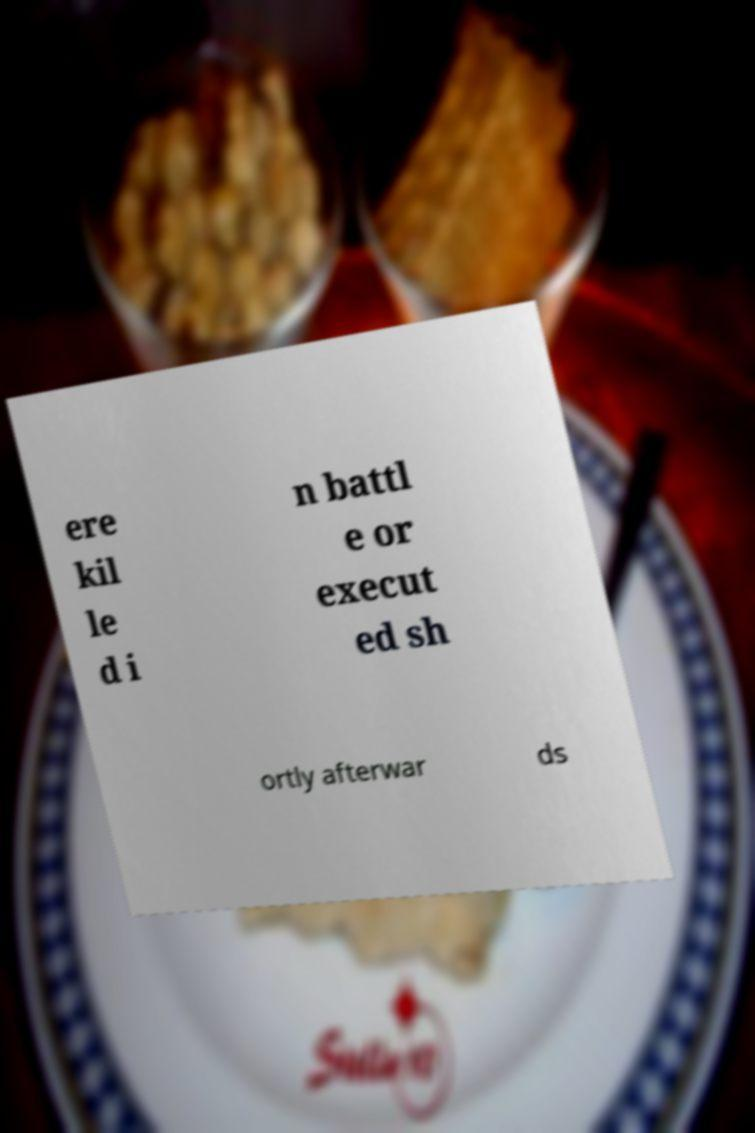Could you assist in decoding the text presented in this image and type it out clearly? ere kil le d i n battl e or execut ed sh ortly afterwar ds 